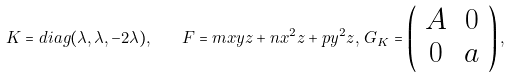<formula> <loc_0><loc_0><loc_500><loc_500>K = d i a g ( \lambda , \lambda , - 2 \lambda ) , \quad F = m x y z + n x ^ { 2 } z + p y ^ { 2 } z , \, G _ { K } = \left ( \begin{array} { c c } A & 0 \\ 0 & a \end{array} \right ) ,</formula> 